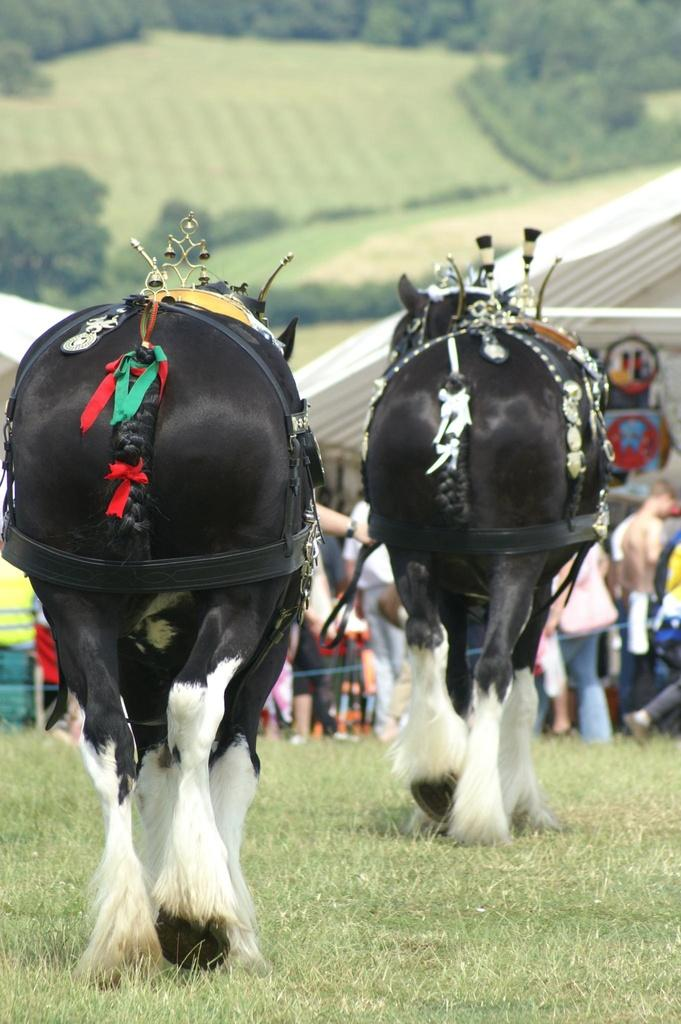What animals are present on the ground in the image? There are two decorated horses on the ground. What type of terrain can be seen in the image? There is grass visible in the image. Where are the people located in the image? There is a group of people under a tent. What type of vegetation is visible in the background of the image? There is a group of trees on the backside of the image. What is the price of the necklace worn by the horse in the image? There is no necklace or price mentioned in the image; it features two decorated horses on the ground. 